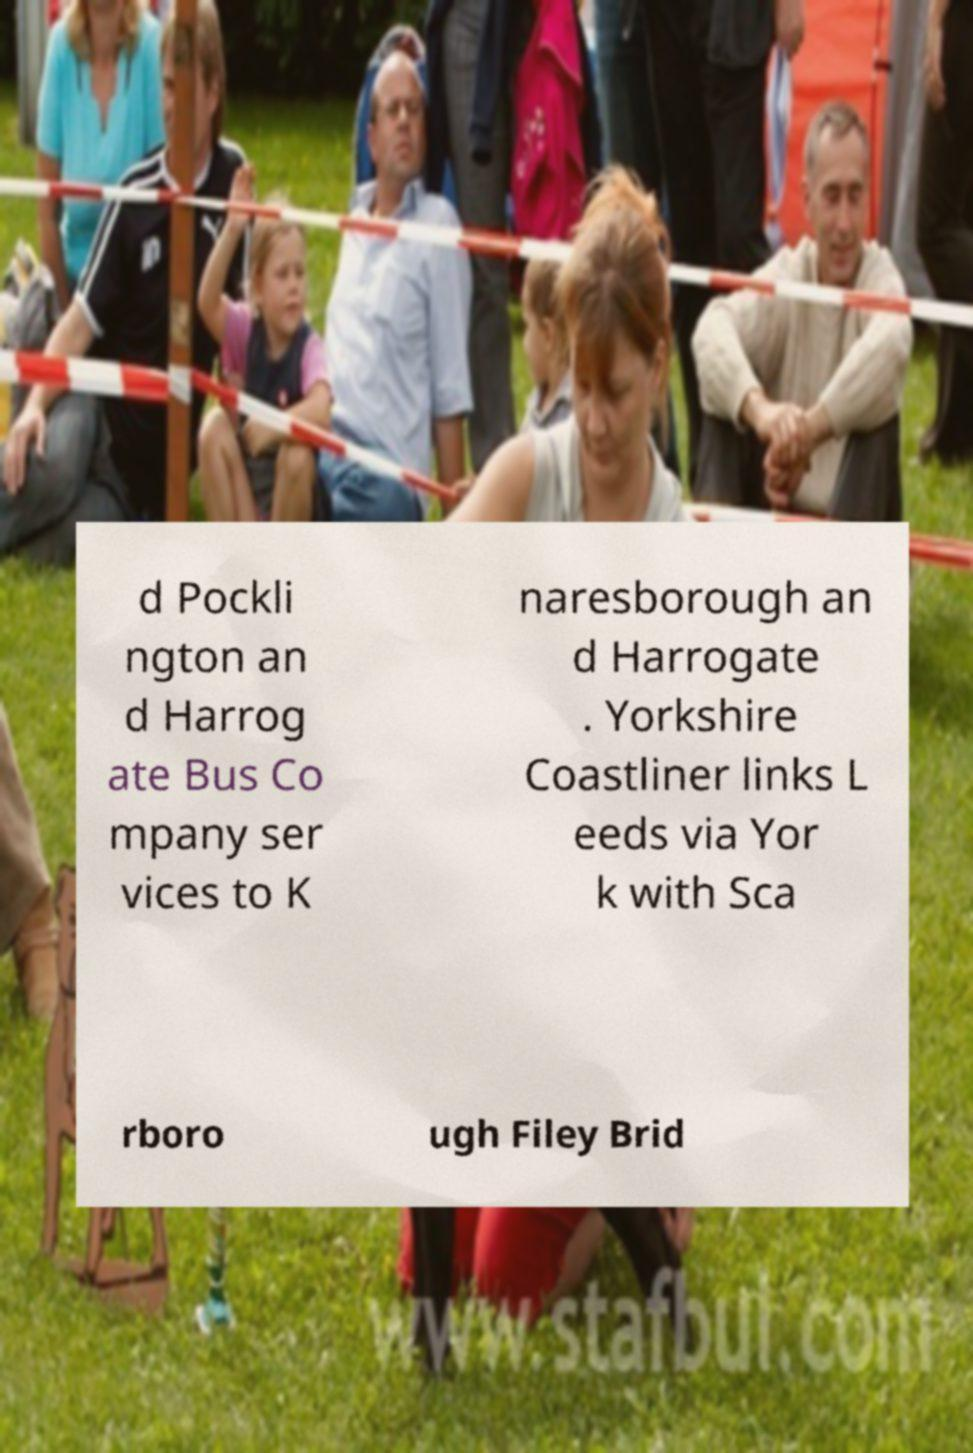Please read and relay the text visible in this image. What does it say? d Pockli ngton an d Harrog ate Bus Co mpany ser vices to K naresborough an d Harrogate . Yorkshire Coastliner links L eeds via Yor k with Sca rboro ugh Filey Brid 